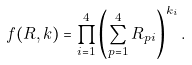<formula> <loc_0><loc_0><loc_500><loc_500>f ( R , k ) = \prod _ { i = 1 } ^ { 4 } \left ( \sum _ { p = 1 } ^ { 4 } R _ { p i } \right ) ^ { k _ { i } } .</formula> 